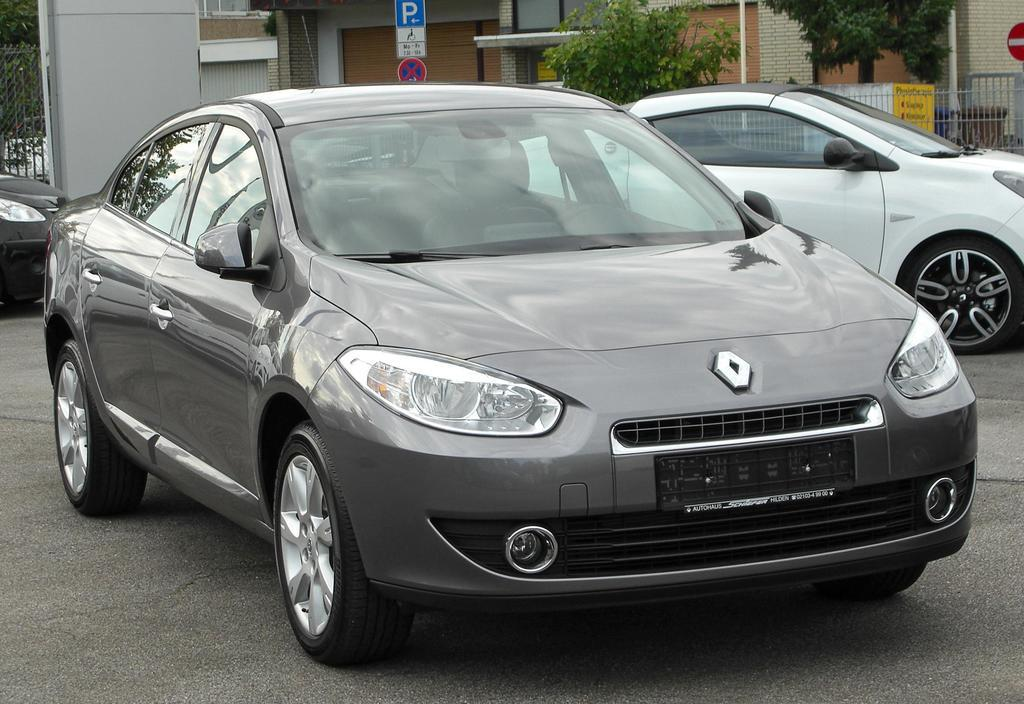What is parked on the road in the image? There is a car parked on the road in the image. What can be seen in the background of the image? In the background, there are vehicles, walls, houses, trees, sign boards, grills, pillars, and poles visible. How many ladybugs are crawling on the car in the image? There are no ladybugs present on the car in the image. What type of pump is visible in the background? There is no pump visible in the background of the image. 